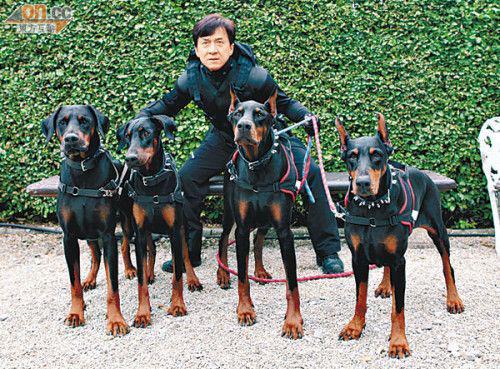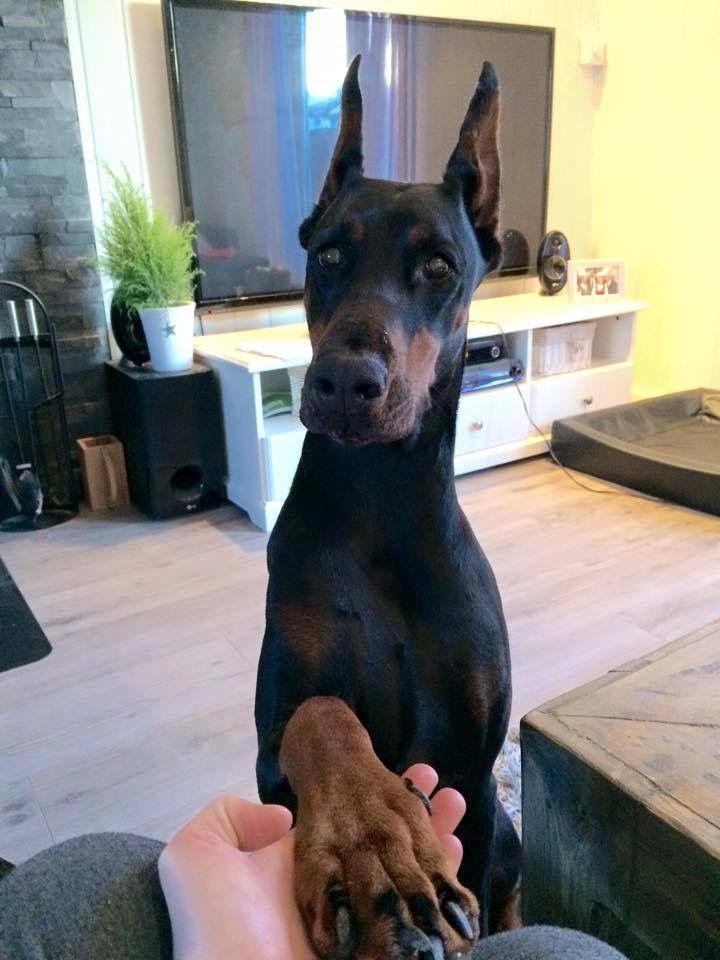The first image is the image on the left, the second image is the image on the right. Examine the images to the left and right. Is the description "There are more dogs in the image on the right" accurate? Answer yes or no. No. The first image is the image on the left, the second image is the image on the right. Evaluate the accuracy of this statement regarding the images: "There are at least five dogs.". Is it true? Answer yes or no. Yes. 